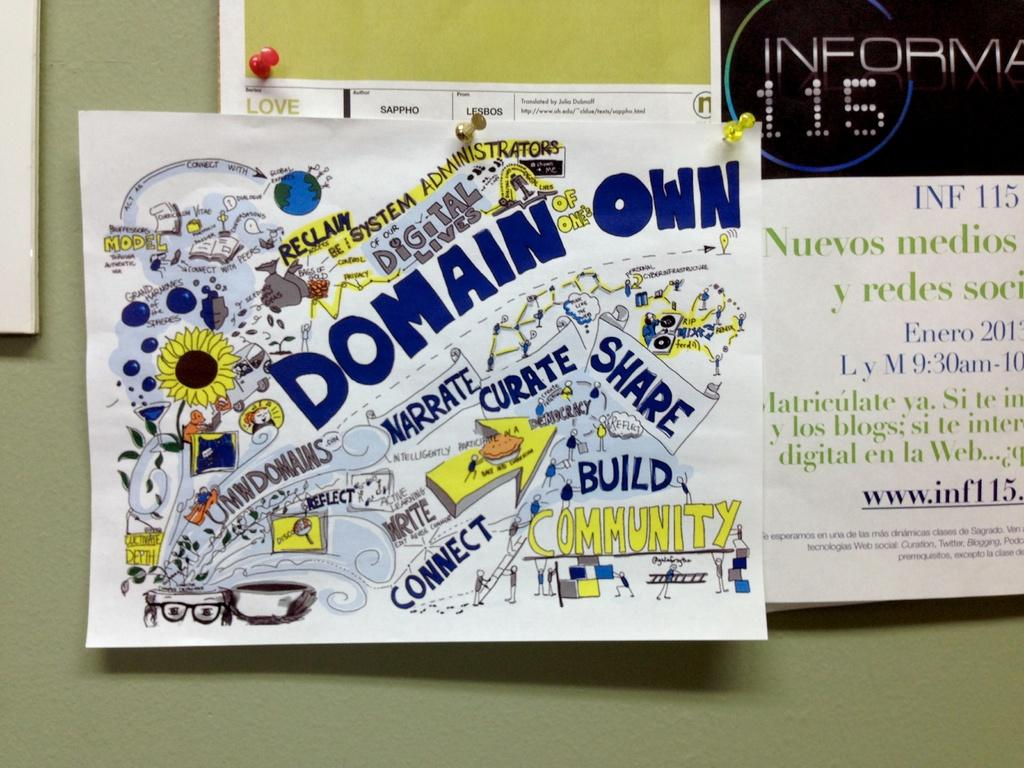What is attached to the notice board in the image? There are papers on a notice board. Can you describe the arrangement of the papers on the notice board? The provided facts do not specify the arrangement of the papers on the notice board. What might the papers on the notice board be related to? The provided facts do not specify the content or purpose of the papers on the notice board. What type of tub can be seen in the image? There is no tub present in the image; it only features papers on a notice board. 